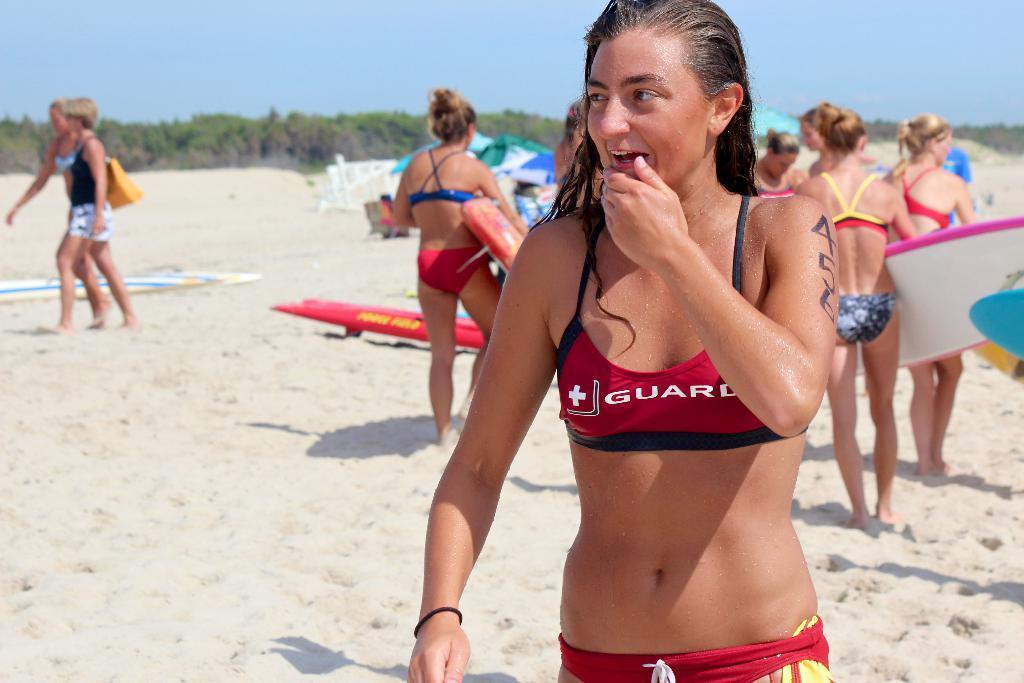Can you describe this image briefly? In the image we can see there are women who are standing and people who are standing on the sand. 